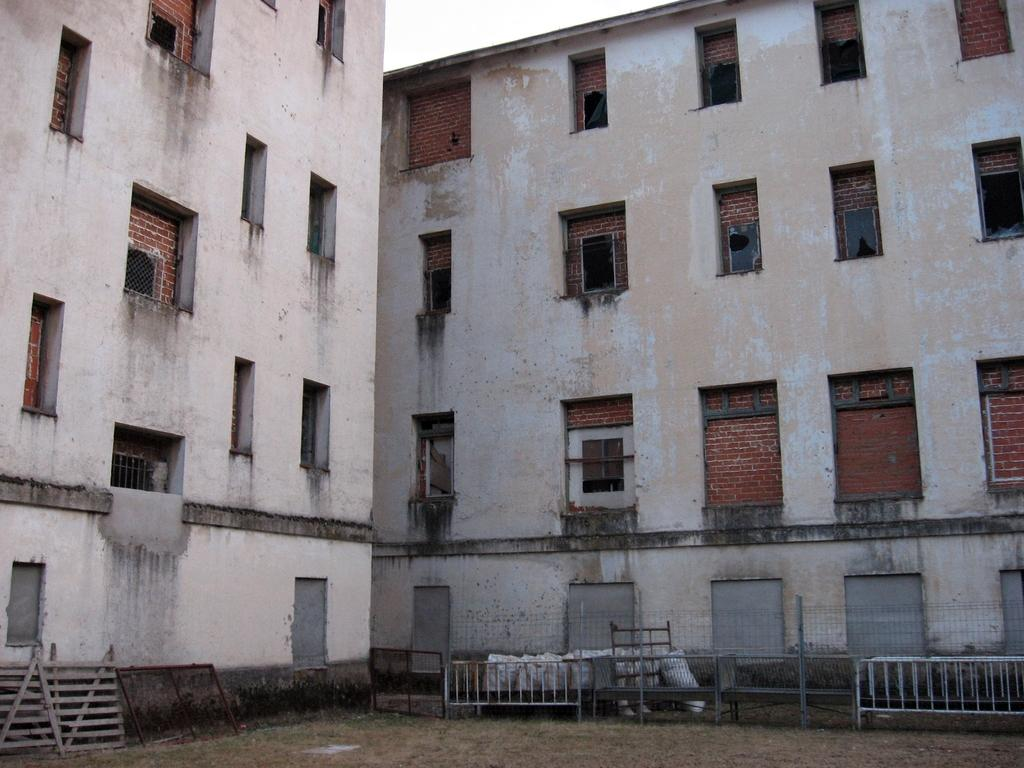How many buildings are visible in the image? There are two buildings in the image. What feature do the buildings have in common? The buildings have windows. What type of fencing can be seen at the bottom of the image? There is a wooden fence at the bottom of the image. What other barrier is present at the bottom of the image? There is an iron gate at the bottom of the image. What additional objects can be seen at the bottom of the image? There are barricades at the bottom of the image, as well as other unspecified objects. What time does the clock on the wall indicate in the image? There is no clock present in the image. Can you describe the grandmother's attire in the image? There is no grandmother present in the image. What type of animal is grazing near the buildings in the image? There is no animal, such as a goat, present in the image. 